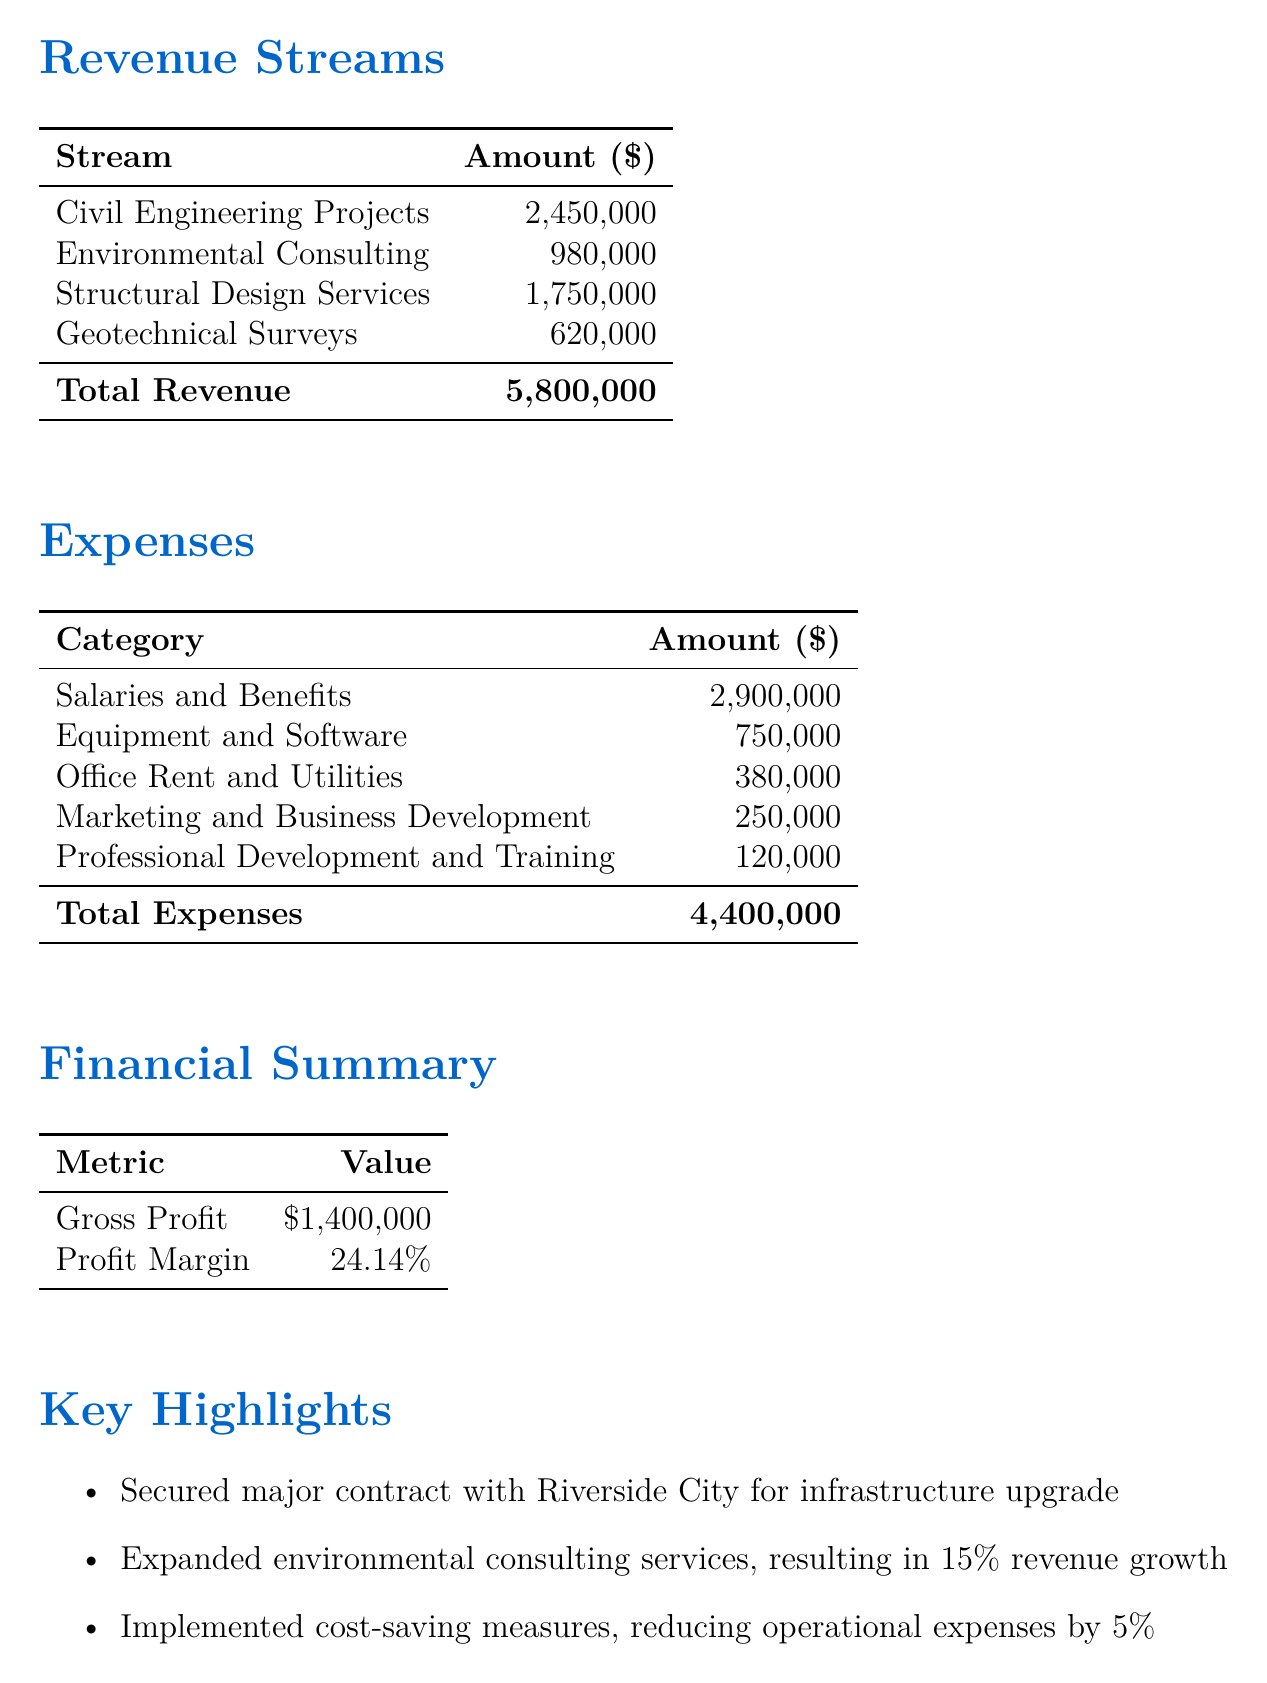What is the total revenue? The total revenue is stated in the document and is the sum of all revenue sources, which equals $5,800,000.
Answer: $5,800,000 What are the expenses for Office Rent and Utilities? The document lists the amount for Office Rent and Utilities as part of the expenses section.
Answer: $380,000 What is the profit margin? The profit margin is provided in the financial summary section of the document as a percentage.
Answer: 24.14% How much revenue did Environmental Consulting generate? The document specifies the revenue amount for Environmental Consulting under revenue streams.
Answer: $980,000 What is the gross profit for Q3 2023? The gross profit is explicitly mentioned in the financial summary part of the document.
Answer: $1,400,000 Which project secured a major contract? The document highlights a significant contract in the key highlights section, specifying the entity involved.
Answer: Riverside City What was the percentage revenue growth from expanded environmental consulting services? This detail is included in the key highlights section, indicating the impact on revenue.
Answer: 15% What was the total amount spent on Salaries and Benefits? The expense amount for Salaries and Benefits is detailed in the expenses section of the document.
Answer: $2,900,000 What future outlook is mentioned for Q4? The document provides insights regarding expectations for future growth and demand in the future outlook section.
Answer: Positive growth expected 